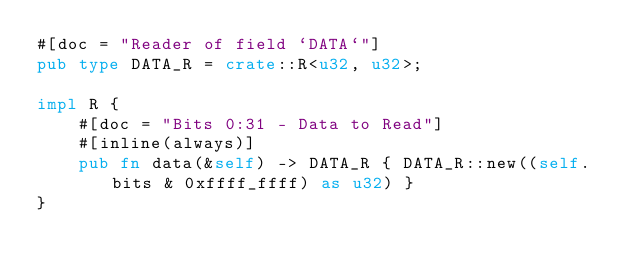Convert code to text. <code><loc_0><loc_0><loc_500><loc_500><_Rust_>#[doc = "Reader of field `DATA`"]
pub type DATA_R = crate::R<u32, u32>;

impl R {
    #[doc = "Bits 0:31 - Data to Read"]
    #[inline(always)]
    pub fn data(&self) -> DATA_R { DATA_R::new((self.bits & 0xffff_ffff) as u32) }
}</code> 